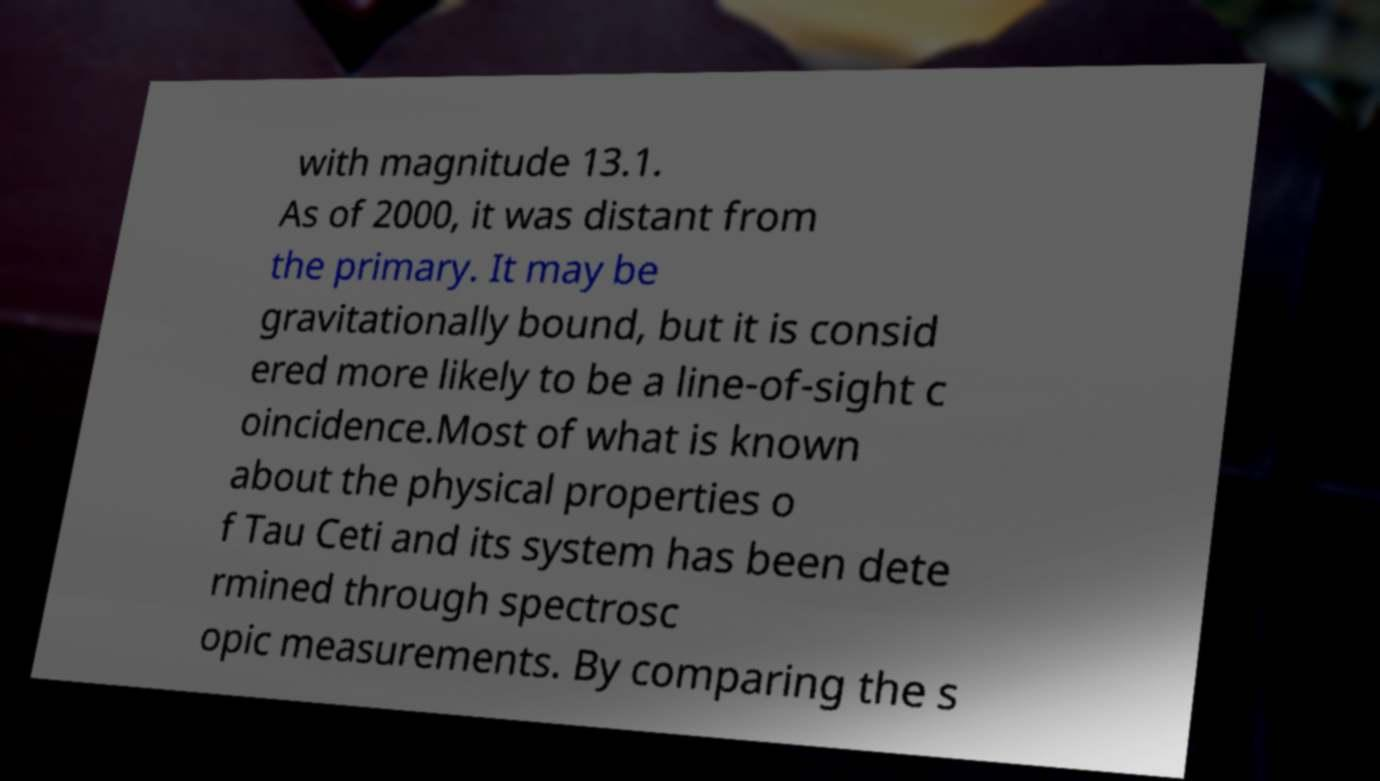Could you assist in decoding the text presented in this image and type it out clearly? with magnitude 13.1. As of 2000, it was distant from the primary. It may be gravitationally bound, but it is consid ered more likely to be a line-of-sight c oincidence.Most of what is known about the physical properties o f Tau Ceti and its system has been dete rmined through spectrosc opic measurements. By comparing the s 